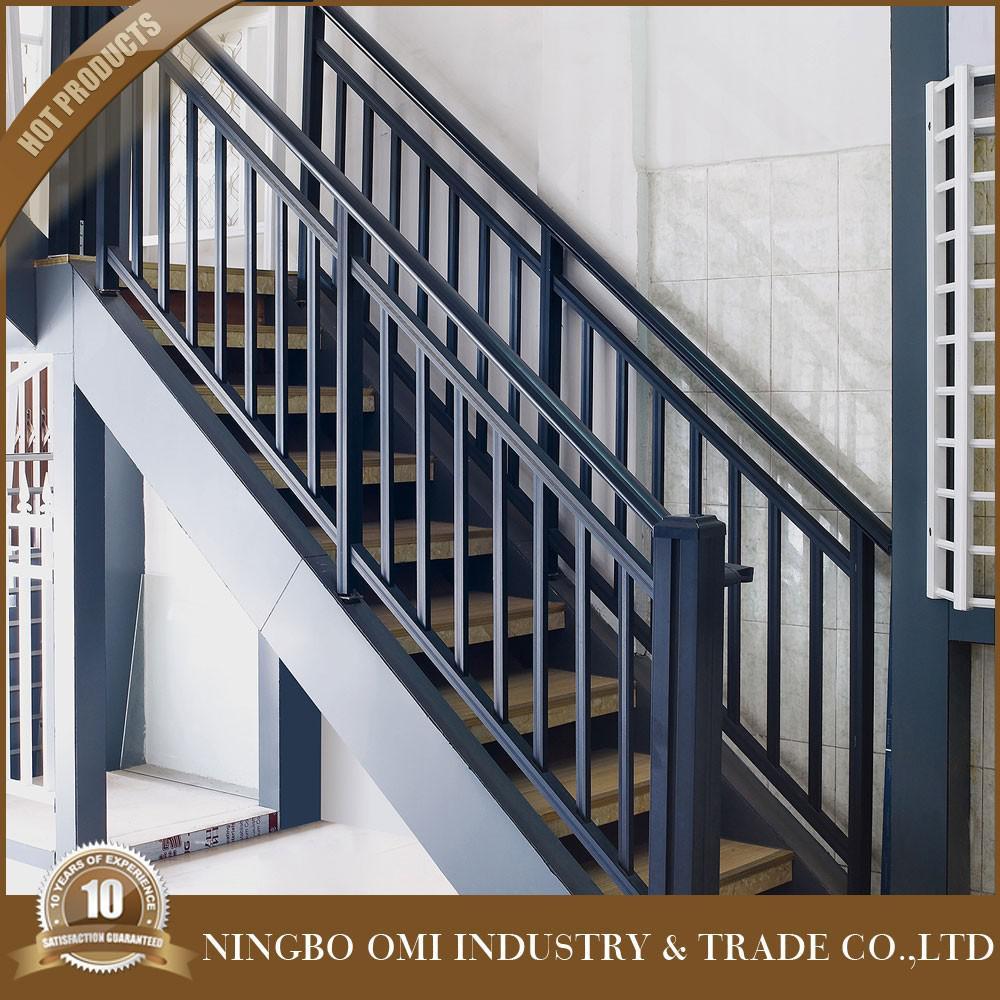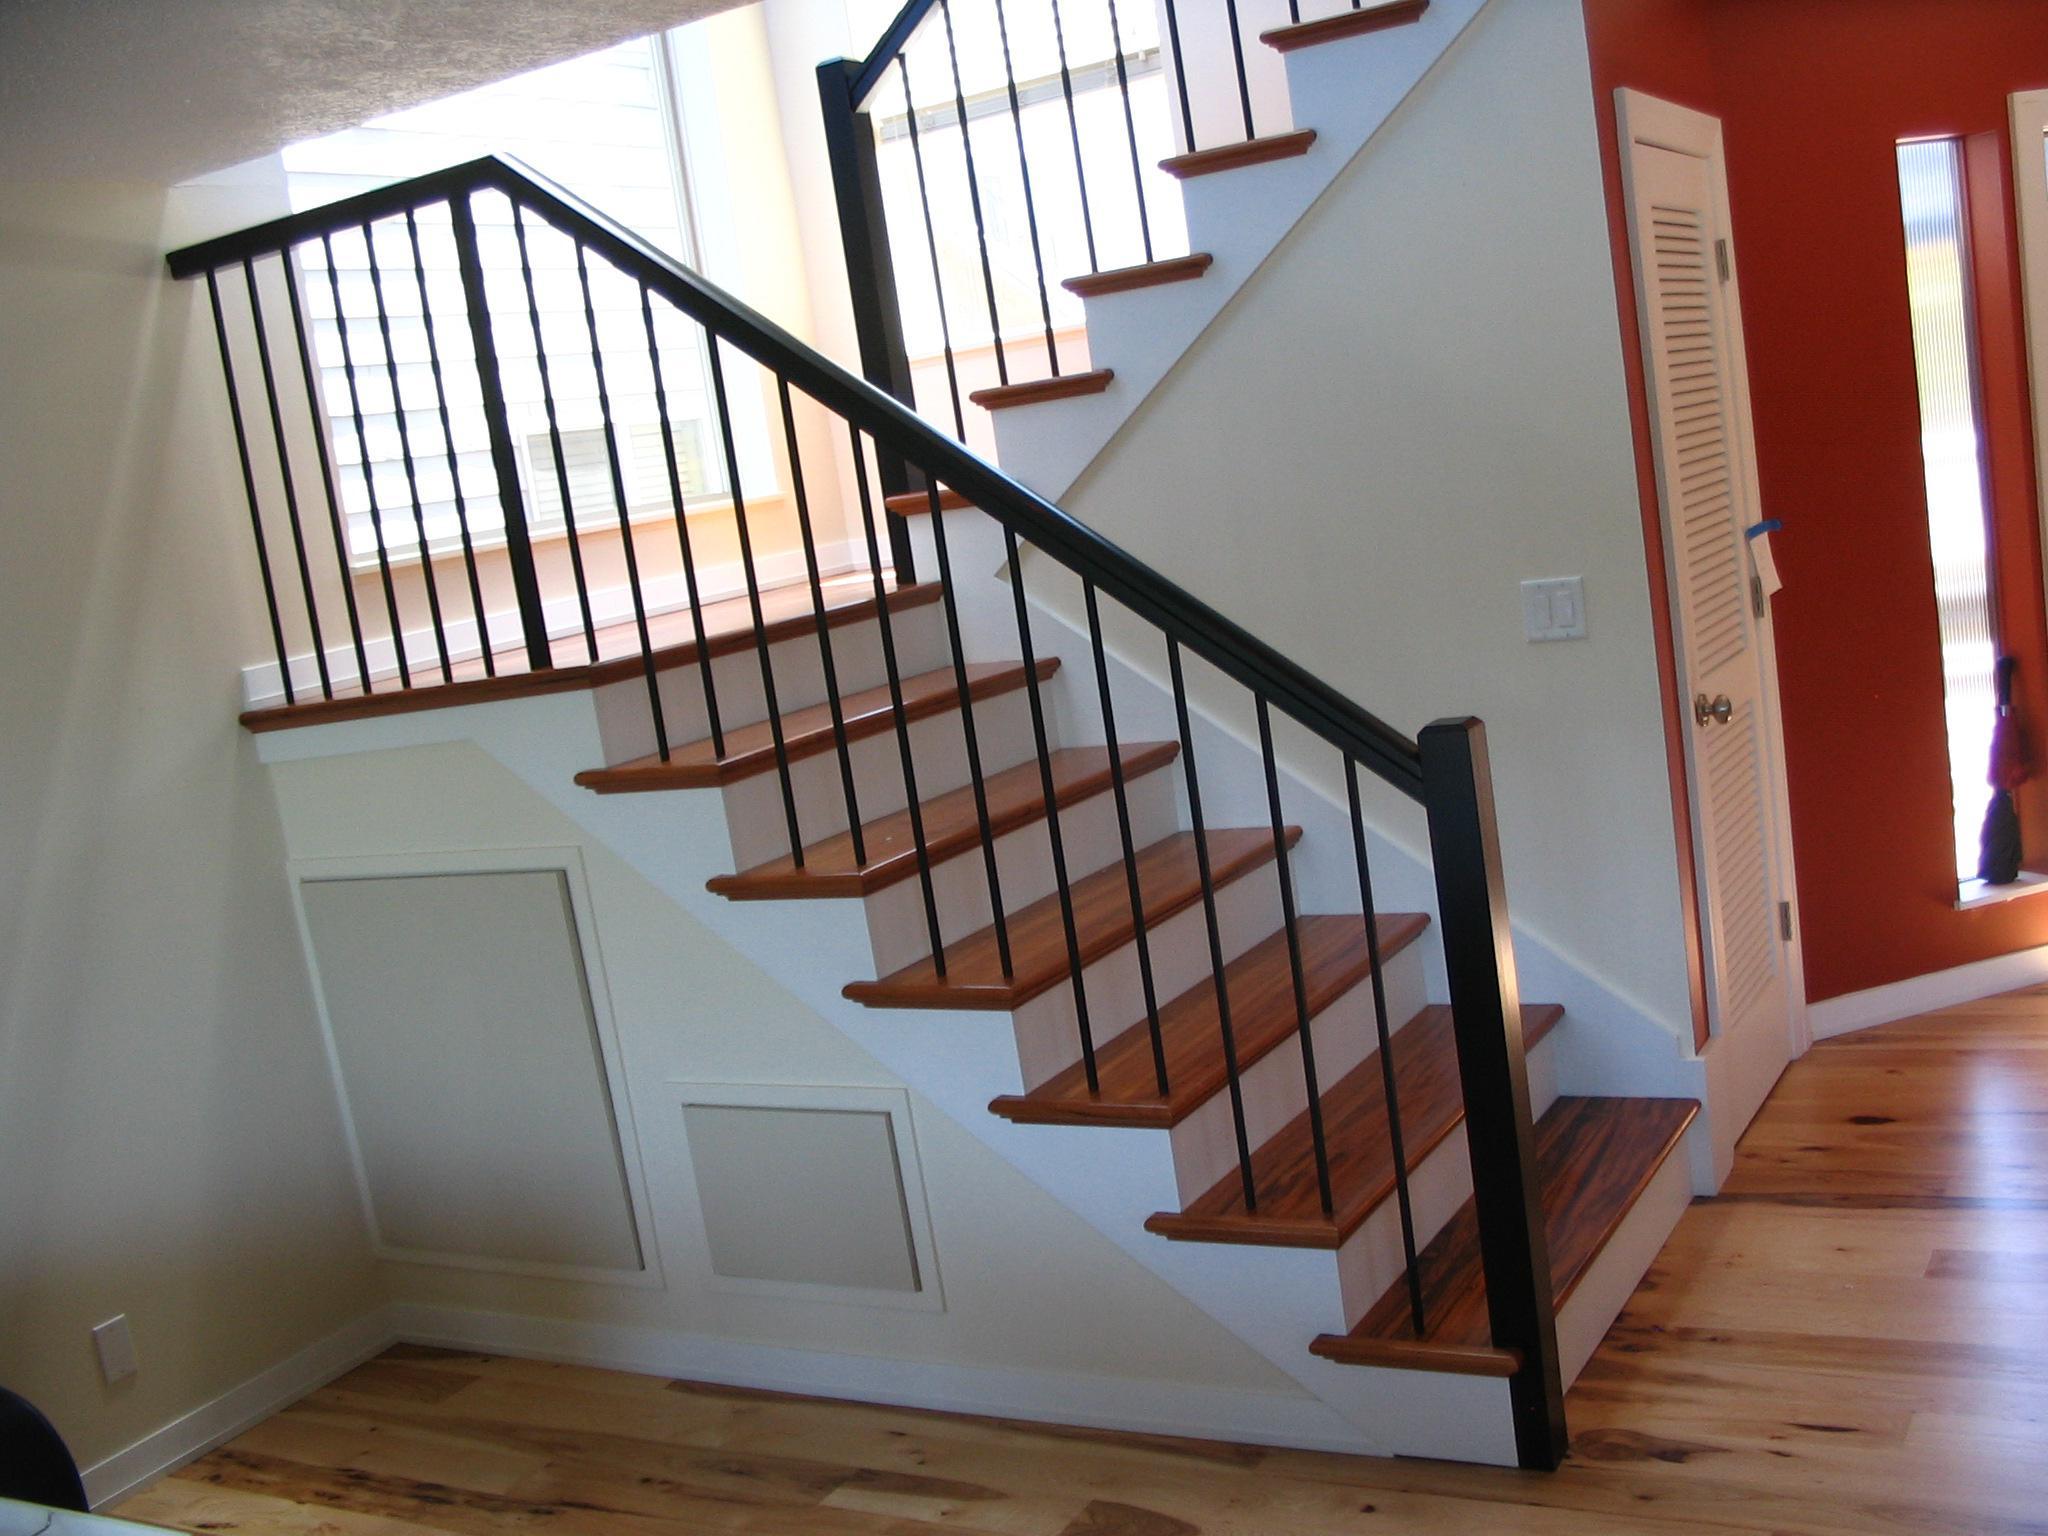The first image is the image on the left, the second image is the image on the right. Evaluate the accuracy of this statement regarding the images: "Exactly one stairway changes directions.". Is it true? Answer yes or no. Yes. The first image is the image on the left, the second image is the image on the right. Examine the images to the left and right. Is the description "Each image features a staircase that ascends diagonally from the lower left and has wrought iron bars with some type of decorative embellishment." accurate? Answer yes or no. No. 